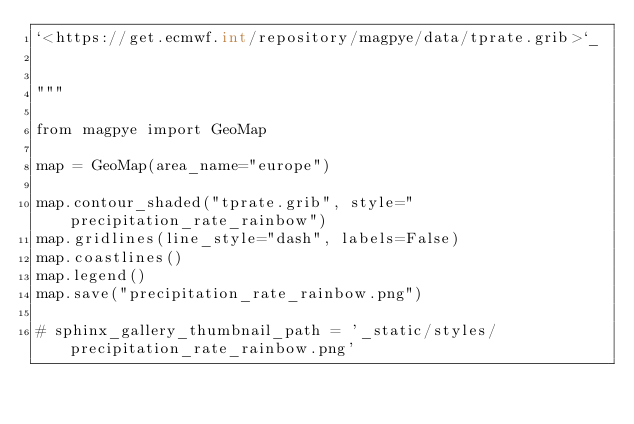<code> <loc_0><loc_0><loc_500><loc_500><_Python_>`<https://get.ecmwf.int/repository/magpye/data/tprate.grib>`_


"""

from magpye import GeoMap

map = GeoMap(area_name="europe")

map.contour_shaded("tprate.grib", style="precipitation_rate_rainbow")
map.gridlines(line_style="dash", labels=False)
map.coastlines()
map.legend()
map.save("precipitation_rate_rainbow.png")

# sphinx_gallery_thumbnail_path = '_static/styles/precipitation_rate_rainbow.png'

    </code> 